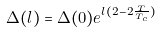<formula> <loc_0><loc_0><loc_500><loc_500>\Delta ( l ) = \Delta ( 0 ) e ^ { l ( 2 - 2 \frac { T } { T _ { c } } ) }</formula> 